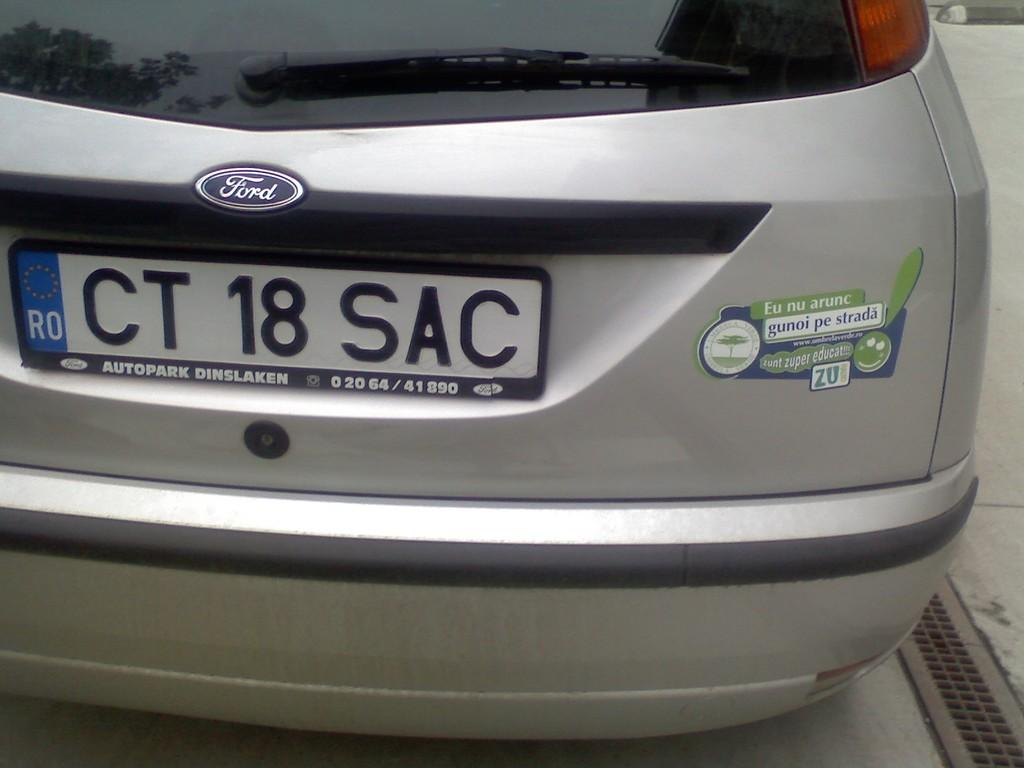<image>
Describe the image concisely. A Ford car has a license plate reading CT 18 SAC. 